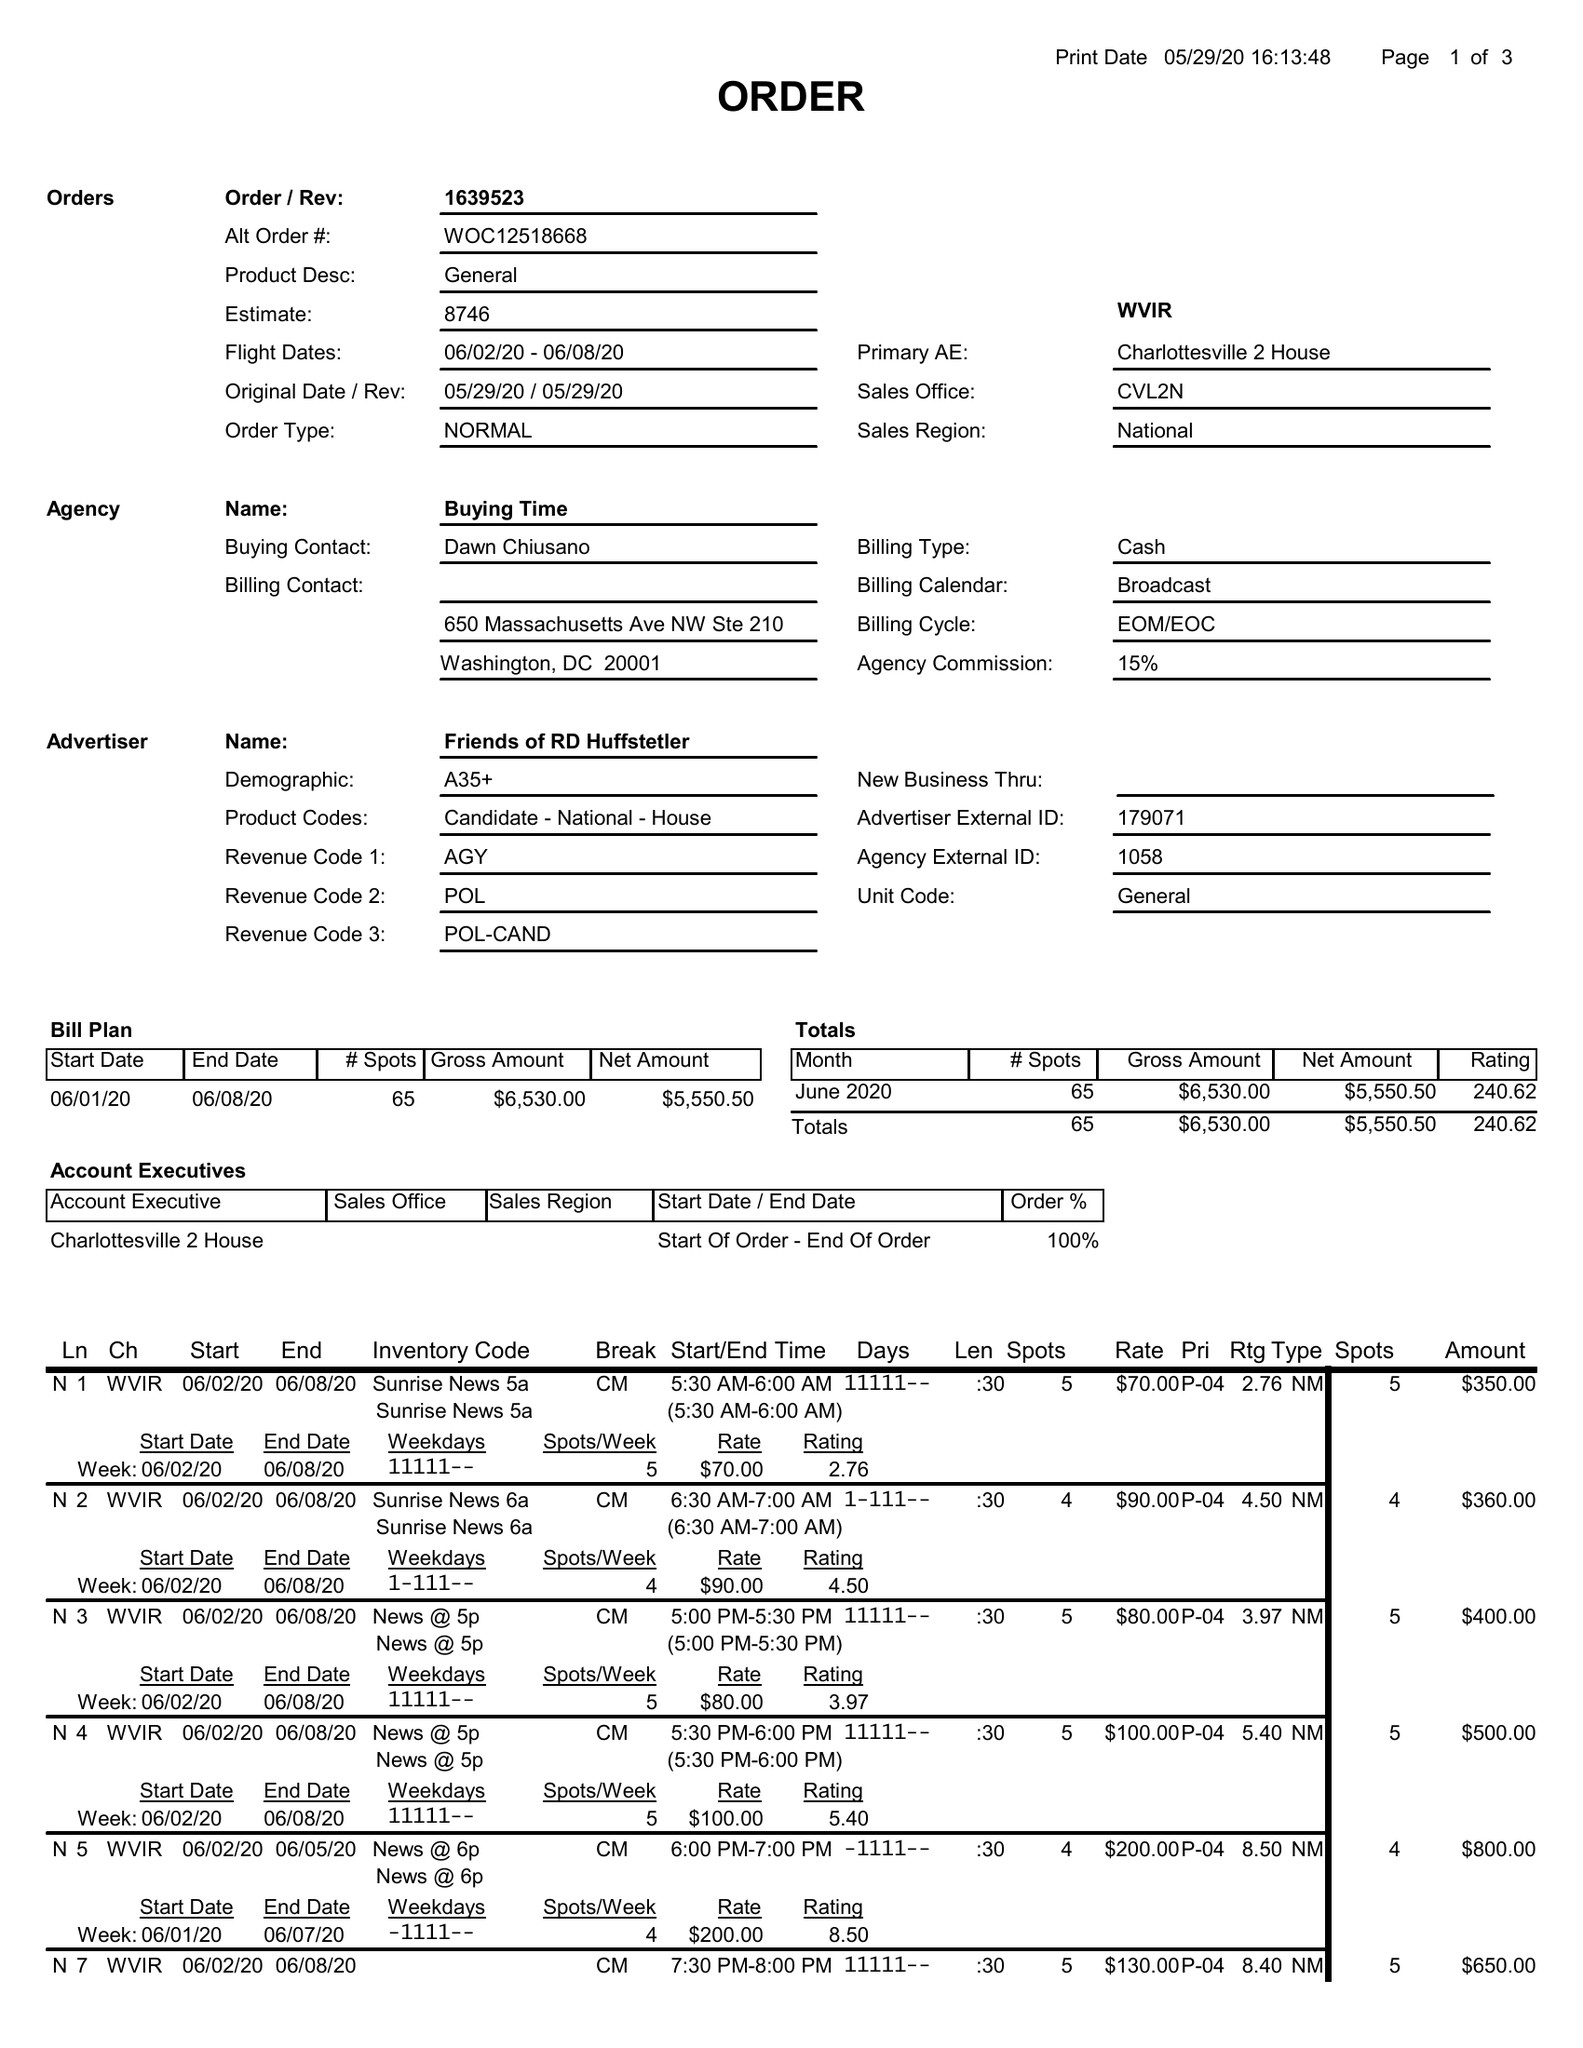What is the value for the gross_amount?
Answer the question using a single word or phrase. 6530.00 